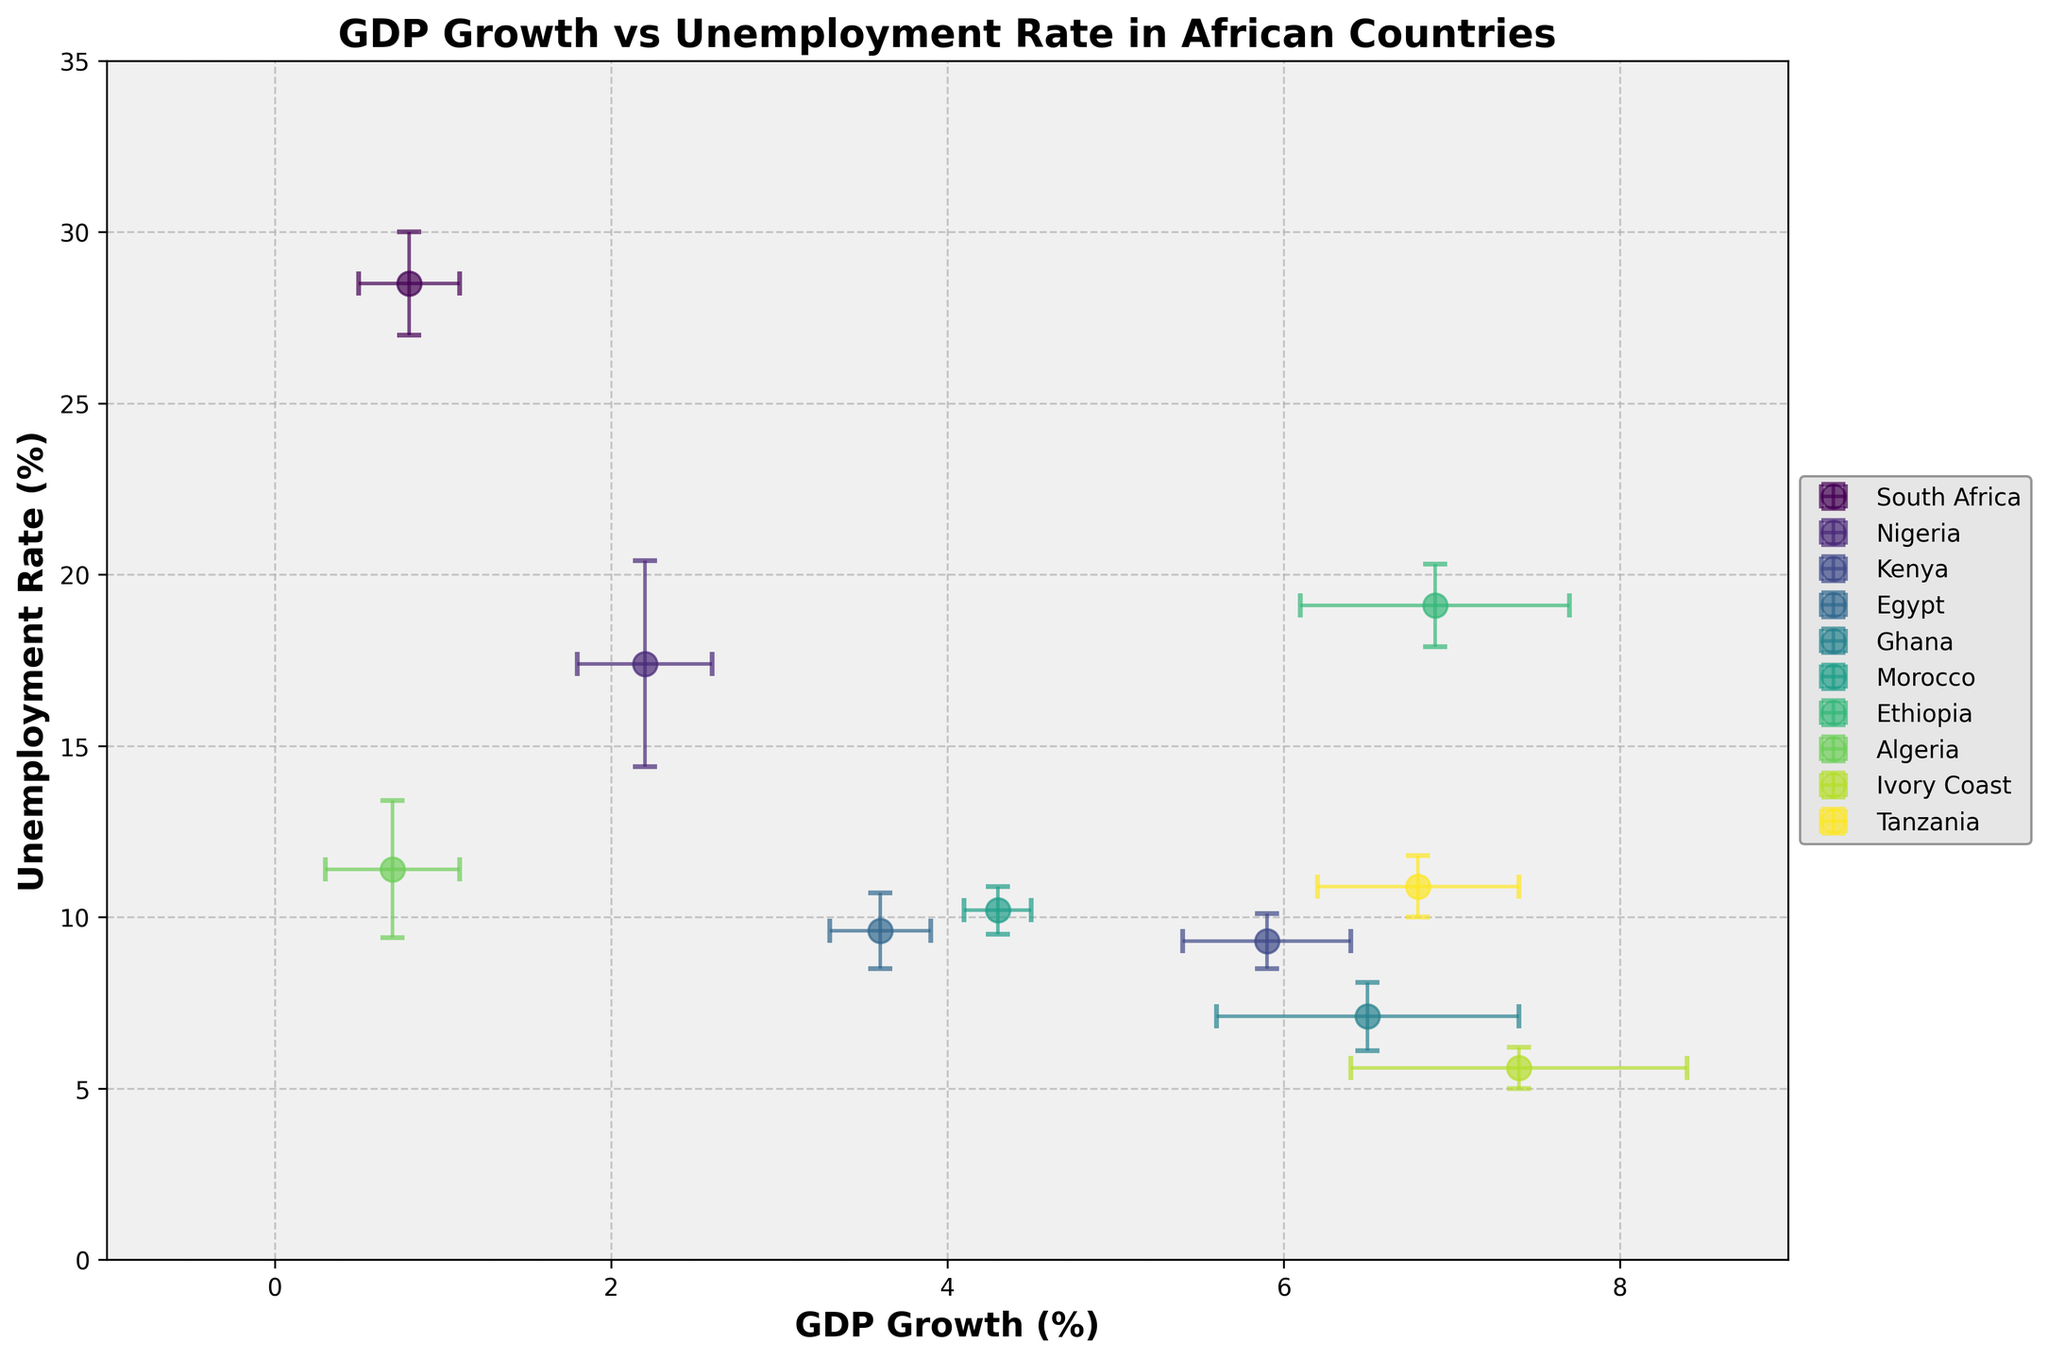What is the title of the plot? The title is typically found at the top center of the graph and summarizes the content of the plot. The title in this plot is "GDP Growth vs Unemployment Rate in African Countries".
Answer: GDP Growth vs Unemployment Rate in African Countries Which country has the highest unemployment rate? Looking at the vertical axis labeled "Unemployment Rate (%)" and identifying the point furthest up on that axis, we see "South Africa" at an unemployment rate of 28.5%.
Answer: South Africa What is the unemployment rate of Ghana? Locate the data point labeled "Ghana" and check its vertical position relative to the "Unemployment Rate (%)" axis. Ghana's unemployment rate is 7.1%.
Answer: 7.1% Which country has the highest GDP growth? By examining the horizontal axis labeled "GDP Growth (%)" and finding the point furthest to the right, we can see "Ivory Coast" with a GDP growth rate of 7.4%.
Answer: Ivory Coast How many countries have a GDP growth rate higher than 5%? Identify the data points to the right of the 5% mark on the "GDP Growth (%)" axis. The countries with GDP growth rates higher than 5% are Kenya, Ghana, Ethiopia, Ivory Coast, and Tanzania. This makes 5 countries.
Answer: 5 Which country has both high GDP growth and low unemployment rate? We need a country with a high value on the horizontal "GDP Growth (%)" axis and a low value on the vertical "Unemployment Rate (%)" axis. "Ivory Coast" has 7.4% GDP growth and 5.6% unemployment rate, meeting this criterion.
Answer: Ivory Coast How does Nigeria's uncertainty in GDP growth compare to its uncertainty in unemployment rate? Look at the error bars associated with Nigeria's data point. Nigeria's GDP growth uncertainty is represented by a shorter horizontal error bar (0.4) compared to a much longer vertical error bar for unemployment rate (3.0).
Answer: Nigeria's uncertainty in unemployment rate is greater Which country shows the least uncertainty in GDP growth? Examine the horizontal error bars and find the shortest one. "Morocco" has the least uncertainty with an error bar of 0.2.
Answer: Morocco Compare the GDP growth and unemployment rate for South Africa and Algeria. Look at South Africa's data point (0.8% GDP growth, 28.5% unemployment) and Algeria's data point (0.7% GDP growth, 11.4% unemployment). Both have similar GDP growth, but South Africa has a much higher unemployment rate.
Answer: South Africa: 0.8% GDP growth, 28.5% unemployment. Algeria: 0.7% GDP growth, 11.4% unemployment Which country has a higher GDP growth, Kenya or Egypt? Find the data points for Kenya (5.9% GDP growth) and Egypt (3.6% GDP growth). Kenya has a higher GDP growth rate than Egypt.
Answer: Kenya 